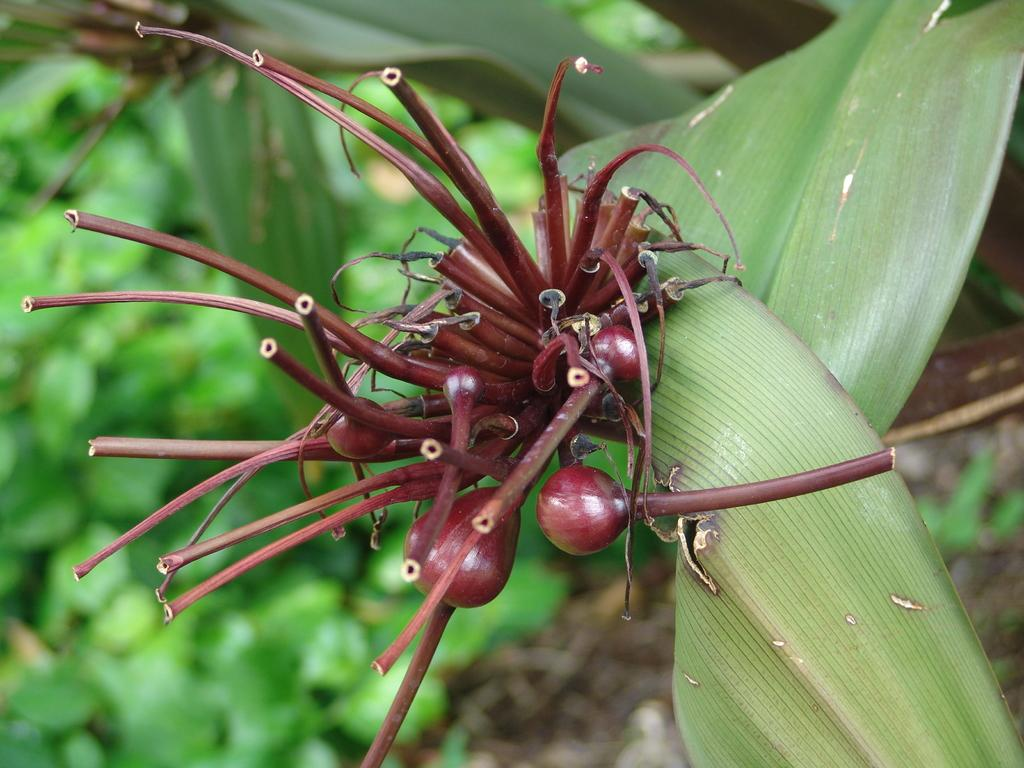What is present in the image? There is a plant in the image. Can you describe the colors of the plant? The plant has brown and green colors. What else can be seen in the background of the image? There are other plants in the background of the image. What color are the background plants? The background plants are green in color. What type of oil is being used to create humor in the image? There is no oil or humor present in the image; it features a plant and other plants in the background. 